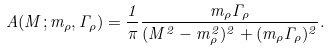<formula> <loc_0><loc_0><loc_500><loc_500>A ( M ; m _ { \rho } , \Gamma _ { \rho } ) = \frac { 1 } { \pi } \frac { m _ { \rho } \Gamma _ { \rho } } { ( M ^ { 2 } - m _ { \rho } ^ { 2 } ) ^ { 2 } + ( m _ { \rho } \Gamma _ { \rho } ) ^ { 2 } } .</formula> 